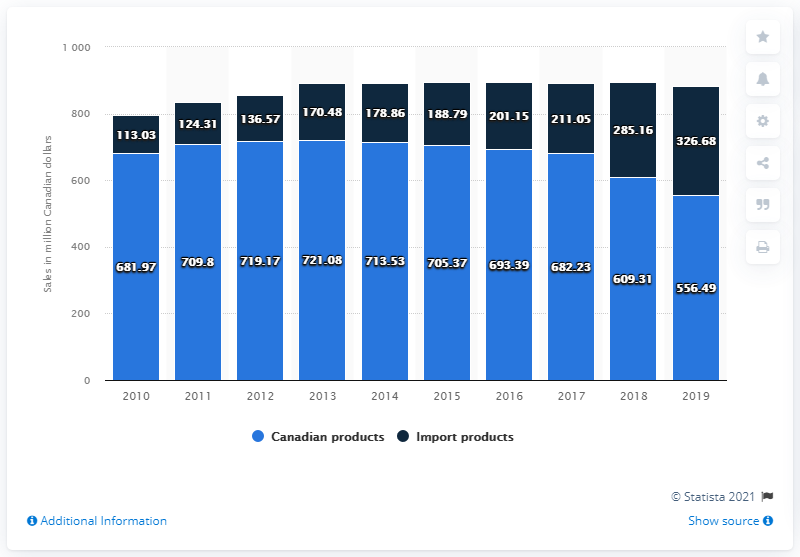Identify some key points in this picture. During the fiscal year ending March 31, 2019, the sales of Canadian rum products were $556.49. The imported rum products generated CAD 326.68 in Canada during the fiscal year ending March 31, 2019. 